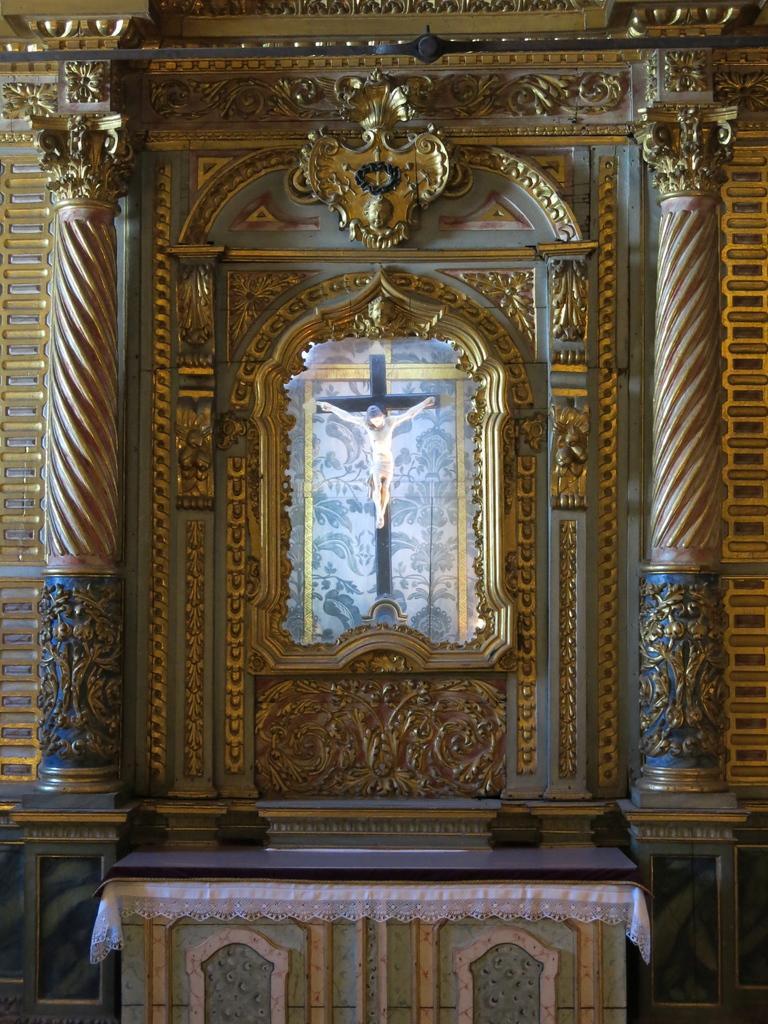How would you summarize this image in a sentence or two? In this image we can see a wall with golden designs. There are pillars. And there is a platform with cloth. In the back we can see a cross with a statue. 